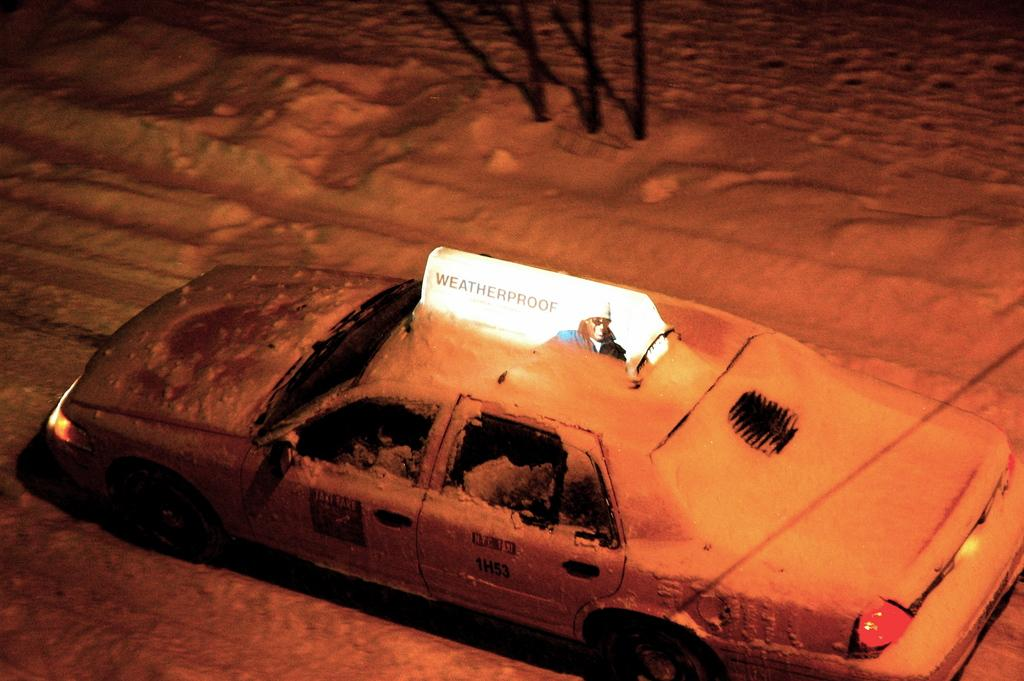<image>
Describe the image concisely. A car in the snow has a sign on the top with the word weatherproof on it. 